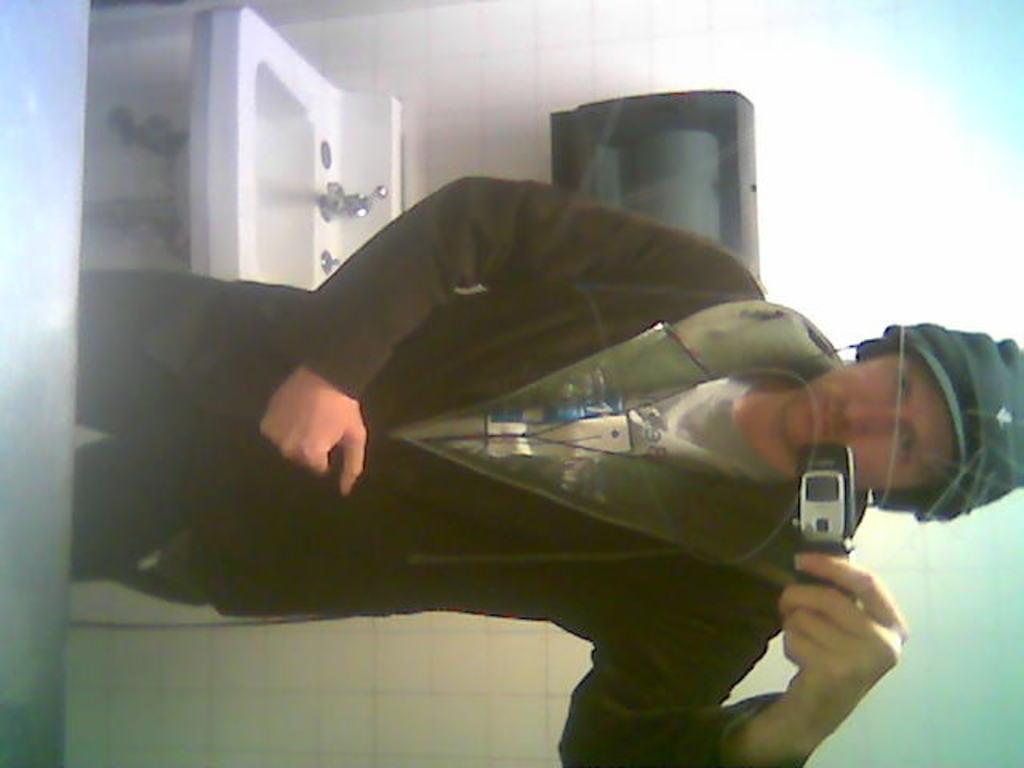In one or two sentences, can you explain what this image depicts? In this image, we can see a person holding a mobile phone. In the background, we can see a wall with an object. We can also see a sink. 